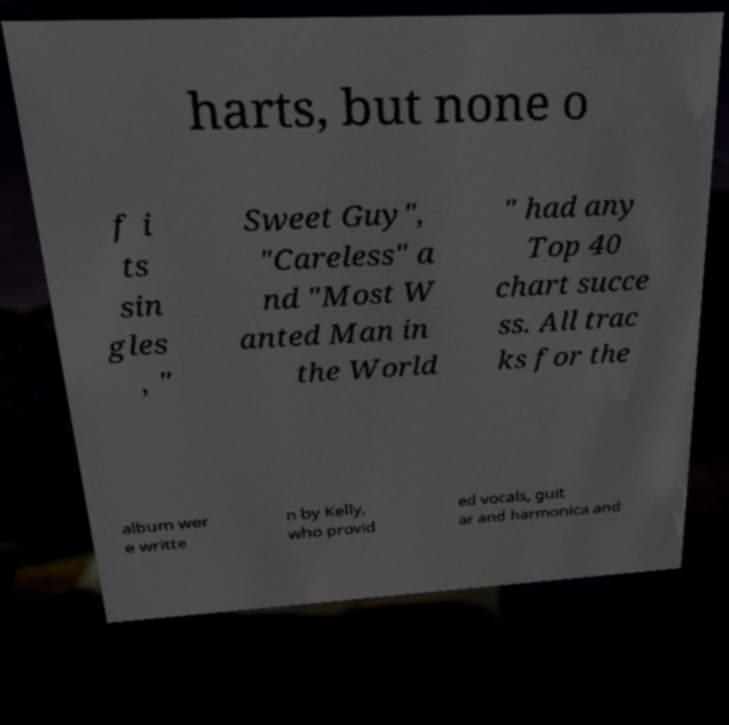Please read and relay the text visible in this image. What does it say? harts, but none o f i ts sin gles , " Sweet Guy", "Careless" a nd "Most W anted Man in the World " had any Top 40 chart succe ss. All trac ks for the album wer e writte n by Kelly, who provid ed vocals, guit ar and harmonica and 